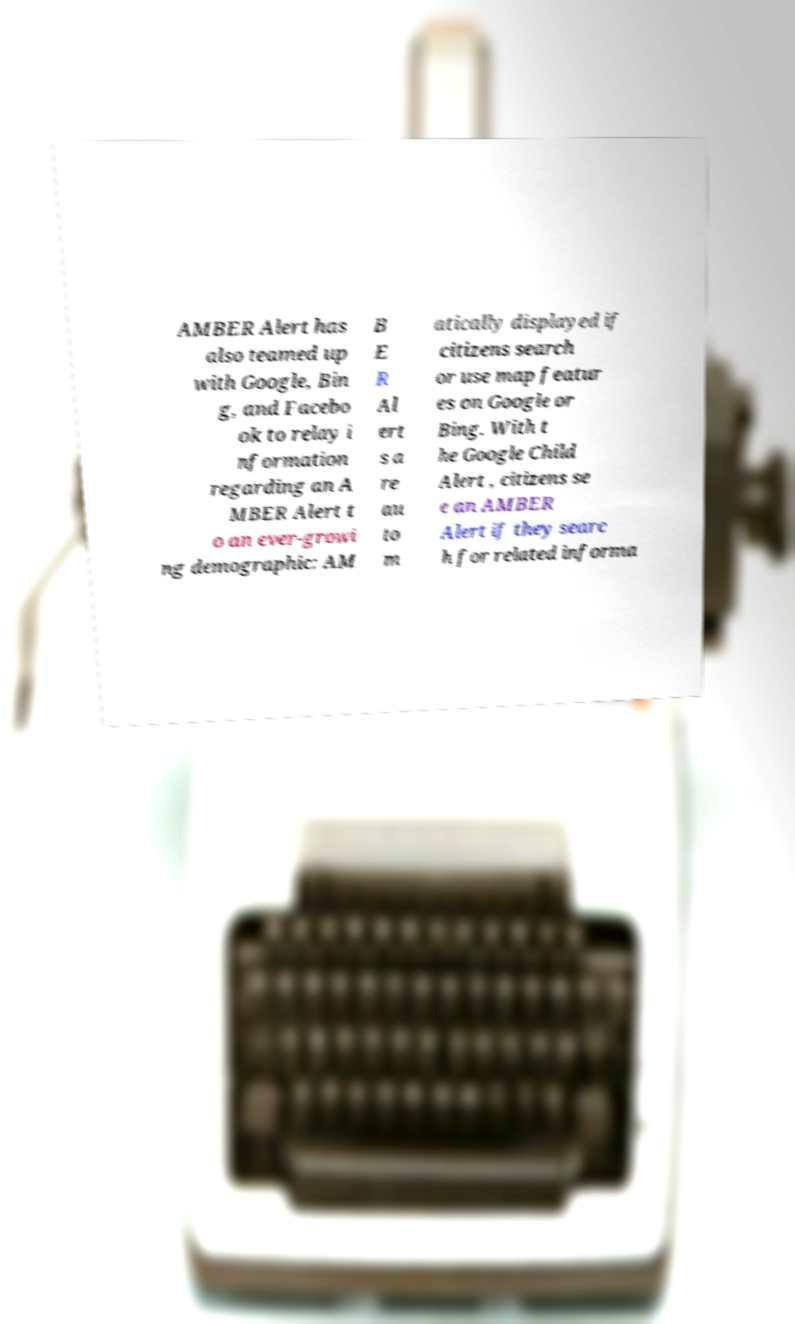Can you accurately transcribe the text from the provided image for me? AMBER Alert has also teamed up with Google, Bin g, and Facebo ok to relay i nformation regarding an A MBER Alert t o an ever-growi ng demographic: AM B E R Al ert s a re au to m atically displayed if citizens search or use map featur es on Google or Bing. With t he Google Child Alert , citizens se e an AMBER Alert if they searc h for related informa 